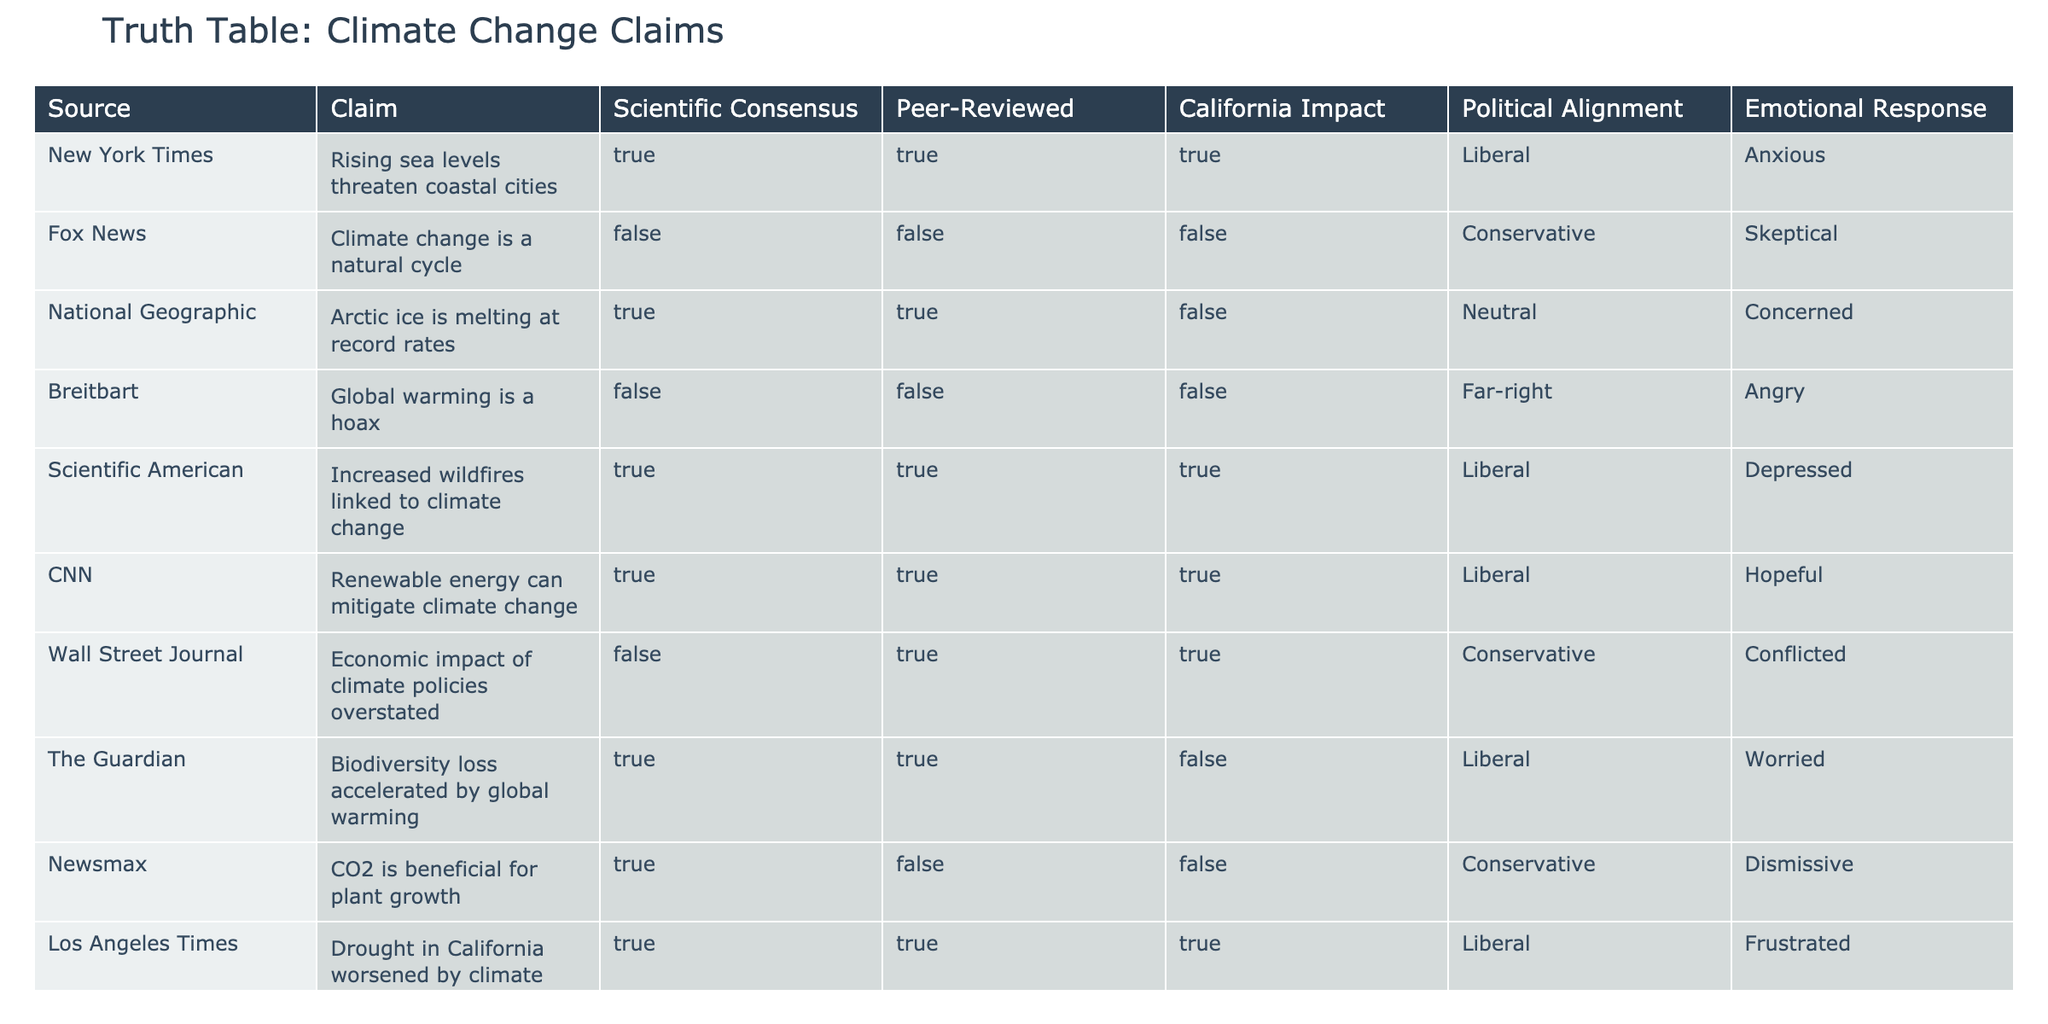What percentage of claims are supported by peer-reviewed research? There are a total of 10 claims listed in the table. Out of these, 6 claims are marked as peer-reviewed (TRUE). To find the percentage, we calculate (6/10) * 100 = 60%.
Answer: 60% Which claim has the highest emotional response? The claim "Global warming is a hoax" associated with Breitbart has the emotional response categorized as "Angry," which is generally a stronger emotional response compared to others.
Answer: Angry Are there any claims that both have a scientific consensus and a California impact? Yes, the claims "Increased wildfires linked to climate change," "Renewable energy can mitigate climate change," and "Drought in California worsened by climate change" all have both a TRUE status for scientific consensus and a TRUE status for California impact.
Answer: Yes Which political alignment has the most false claims? The Conservative political alignment has 3 false claims: "Climate change is a natural cycle," "Global warming is a hoax," and "Economic impact of climate policies overstated." Since it has the highest number of false claims compared to other alignments, it's confirmed that Conservatives have the most.
Answer: Conservative How many claims do not have a scientific consensus? There are 4 claims that do not have a scientific consensus (FALSE): "Climate change is a natural cycle," "Global warming is a hoax," "Economic impact of climate policies overstated," and "CO2 is beneficial for plant growth." Thus, the total is 4.
Answer: 4 Which sources report concern about climate change? The sources that report concern about climate change are National Geographic, Scientific American, CNN, and The Guardian, as indicated by their emotional responses being categorized as "Concerned," "Depressed," "Hopeful," and "Worried," respectively.
Answer: 4 Is there any claim that is both peer-reviewed and has a negative emotional response? Yes, the claim "Increased wildfires linked to climate change" from Scientific American is peer-reviewed and has an emotional response classified as "Depressed," which is a negative response.
Answer: Yes What is the average emotional response among claims with a scientific consensus? The emotional responses for claims with a scientific consensus are: Anxious, Concerned, Depressed, Hopeful, and Worried. To quantify: Assign numerical values (1-Anxious, 2-Concerned, 3-Depressed, 4-Hopeful, 5-Worried). The average would be (1 + 2 + 3 + 4 + 5) / 5 = 3, which corresponds to "Depressed."
Answer: Depressed 